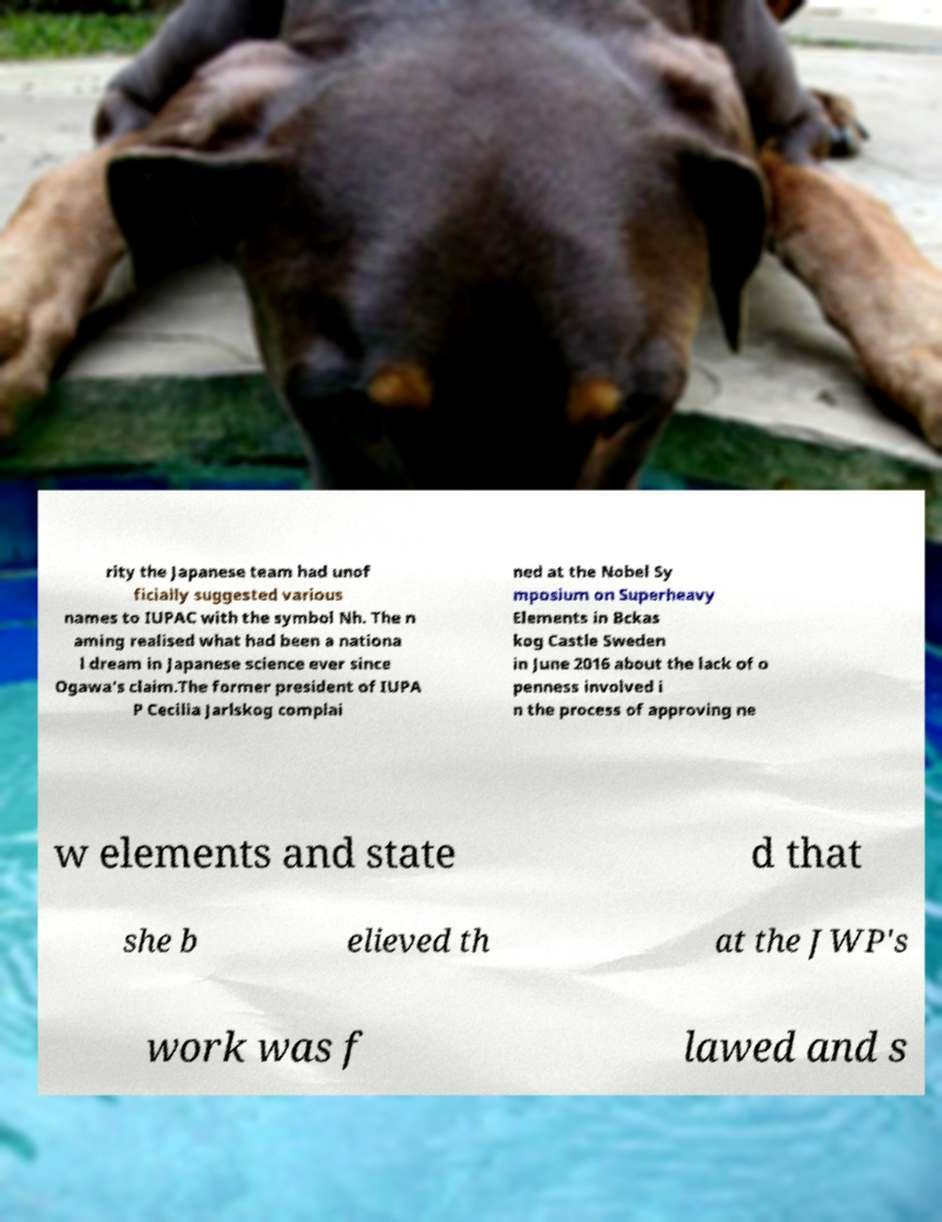Please identify and transcribe the text found in this image. rity the Japanese team had unof ficially suggested various names to IUPAC with the symbol Nh. The n aming realised what had been a nationa l dream in Japanese science ever since Ogawa's claim.The former president of IUPA P Cecilia Jarlskog complai ned at the Nobel Sy mposium on Superheavy Elements in Bckas kog Castle Sweden in June 2016 about the lack of o penness involved i n the process of approving ne w elements and state d that she b elieved th at the JWP's work was f lawed and s 